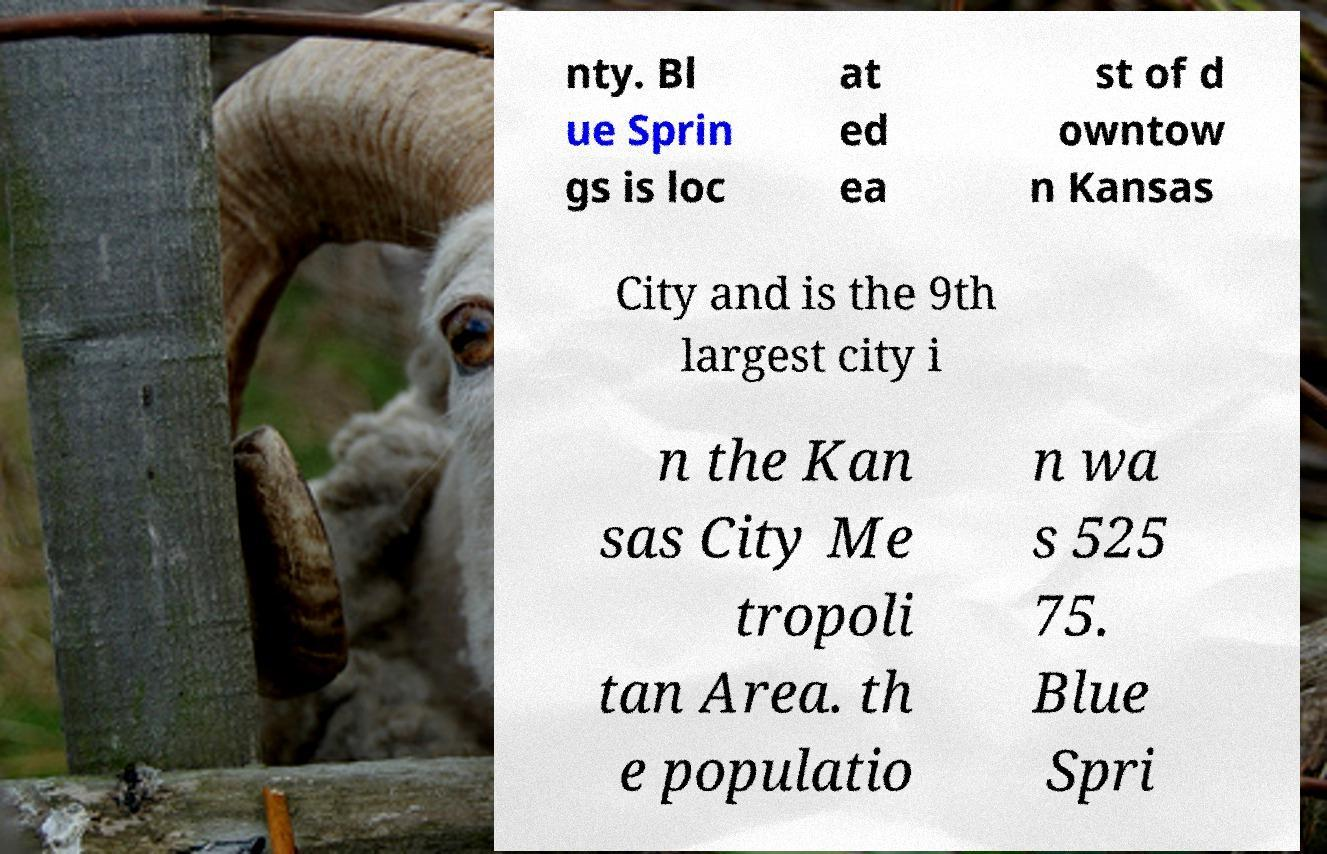Could you assist in decoding the text presented in this image and type it out clearly? nty. Bl ue Sprin gs is loc at ed ea st of d owntow n Kansas City and is the 9th largest city i n the Kan sas City Me tropoli tan Area. th e populatio n wa s 525 75. Blue Spri 